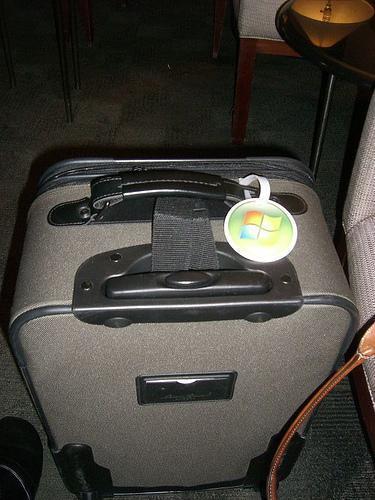How many colors in Microsoft Windows logo?
From the following four choices, select the correct answer to address the question.
Options: Six, one, five, four. Four. 